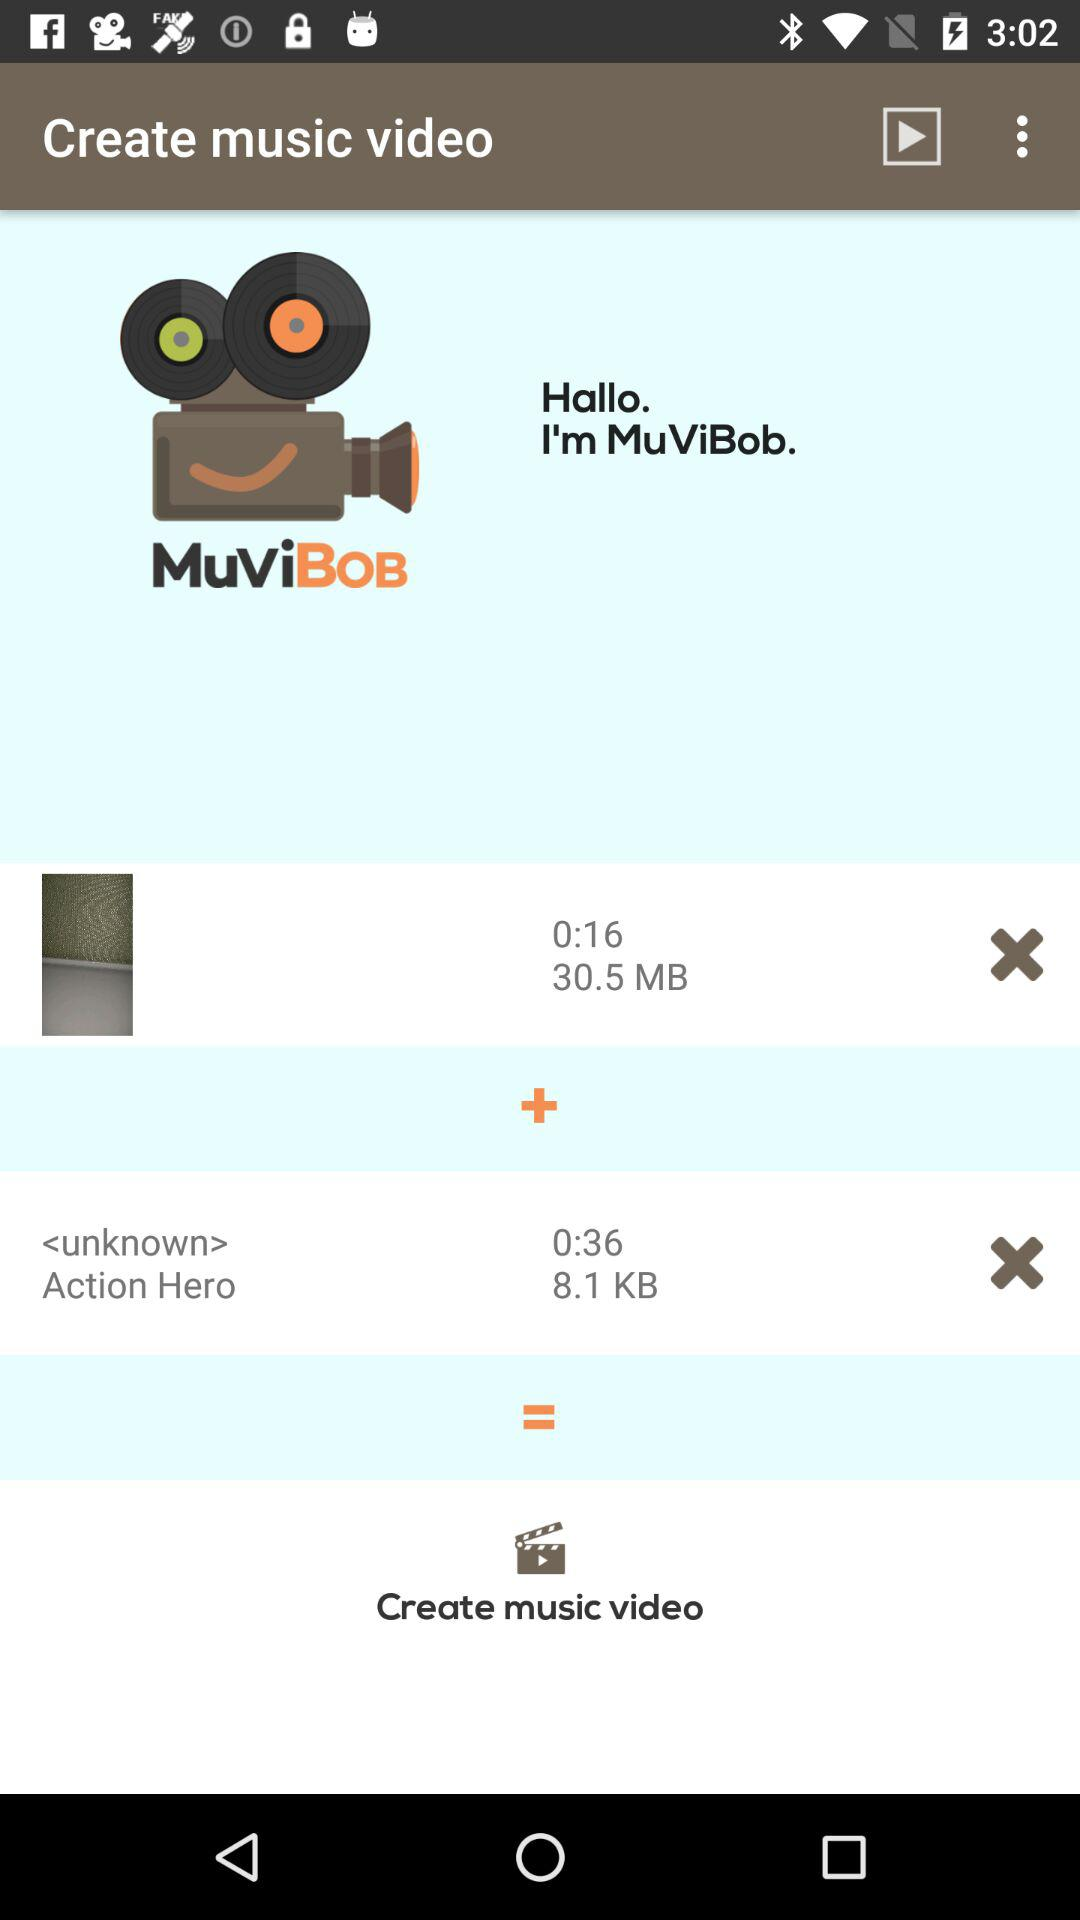What is the time duration of the videos? The duration of the videos is 0:16 and 0:36. 